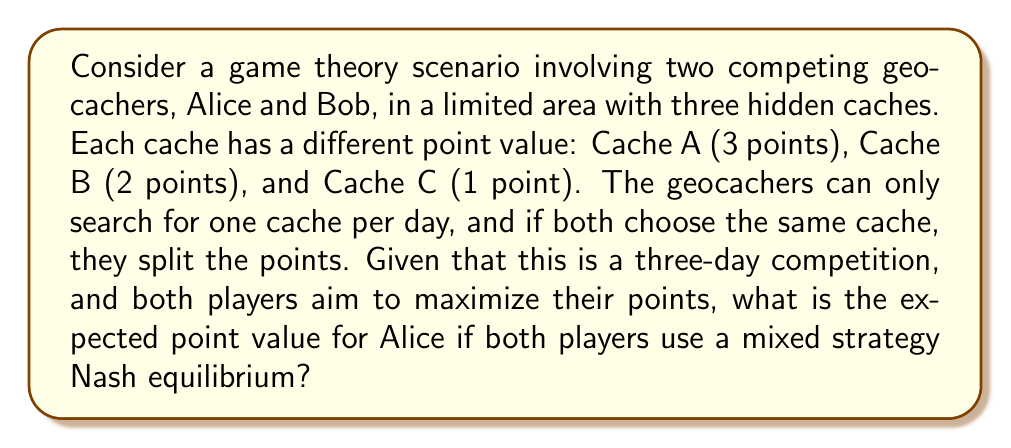Can you answer this question? To solve this problem, we'll follow these steps:

1. Set up the payoff matrix
2. Calculate the mixed strategy Nash equilibrium
3. Determine the expected payoff for Alice

Step 1: Payoff Matrix

Let's create a payoff matrix for a single day:

$$
\begin{array}{c|ccc}
\text{Alice } \backslash \text{ Bob} & \text{Cache A} & \text{Cache B} & \text{Cache C} \\
\hline
\text{Cache A} & (1.5, 1.5) & (3, 2) & (3, 1) \\
\text{Cache B} & (2, 3) & (1, 1) & (2, 1) \\
\text{Cache C} & (1, 3) & (1, 2) & (0.5, 0.5)
\end{array}
$$

Step 2: Mixed Strategy Nash Equilibrium

Let $p$, $q$, and $r$ be the probabilities of choosing Cache A, B, and C respectively for Alice. For Bob, let these probabilities be $x$, $y$, and $z$.

For a mixed strategy Nash equilibrium, the expected payoff for each pure strategy should be equal:

$$1.5x + 3y + 3z = 2x + y + 2z = x + y + 0.5z$$

Solving this system of equations (along with $x + y + z = 1$), we get:

$$x = \frac{5}{12}, y = \frac{1}{3}, z = \frac{1}{4}$$

Due to the symmetry of the game, Alice's probabilities will be the same:

$$p = \frac{5}{12}, q = \frac{1}{3}, r = \frac{1}{4}$$

Step 3: Expected Payoff for Alice

The expected payoff for Alice in a single day is:

$$E = 1.5 \cdot \frac{5}{12} \cdot \frac{5}{12} + 3 \cdot \frac{5}{12} \cdot \frac{1}{3} + 3 \cdot \frac{5}{12} \cdot \frac{1}{4} + 2 \cdot \frac{1}{3} \cdot \frac{5}{12} + 1 \cdot \frac{1}{3} \cdot \frac{1}{3} + 2 \cdot \frac{1}{3} \cdot \frac{1}{4} + 1 \cdot \frac{1}{4} \cdot \frac{5}{12} + 1 \cdot \frac{1}{4} \cdot \frac{1}{3} + 0.5 \cdot \frac{1}{4} \cdot \frac{1}{4}$$

Simplifying:

$$E = \frac{25}{144} + \frac{15}{36} + \frac{15}{48} + \frac{10}{36} + \frac{1}{9} + \frac{1}{6} + \frac{5}{48} + \frac{1}{12} + \frac{1}{32} = \frac{125}{72} \approx 1.736$$

For a three-day competition, the expected total payoff for Alice is:

$$3 \cdot \frac{125}{72} = \frac{125}{24} \approx 5.208$$
Answer: The expected point value for Alice in the three-day competition, assuming both players use a mixed strategy Nash equilibrium, is $\frac{125}{24}$ or approximately 5.208 points. 